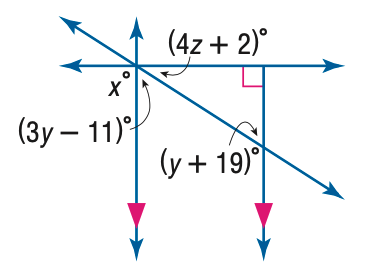Answer the mathemtical geometry problem and directly provide the correct option letter.
Question: Find y in the figure.
Choices: A: 13 B: 13.5 C: 14 D: 15 D 